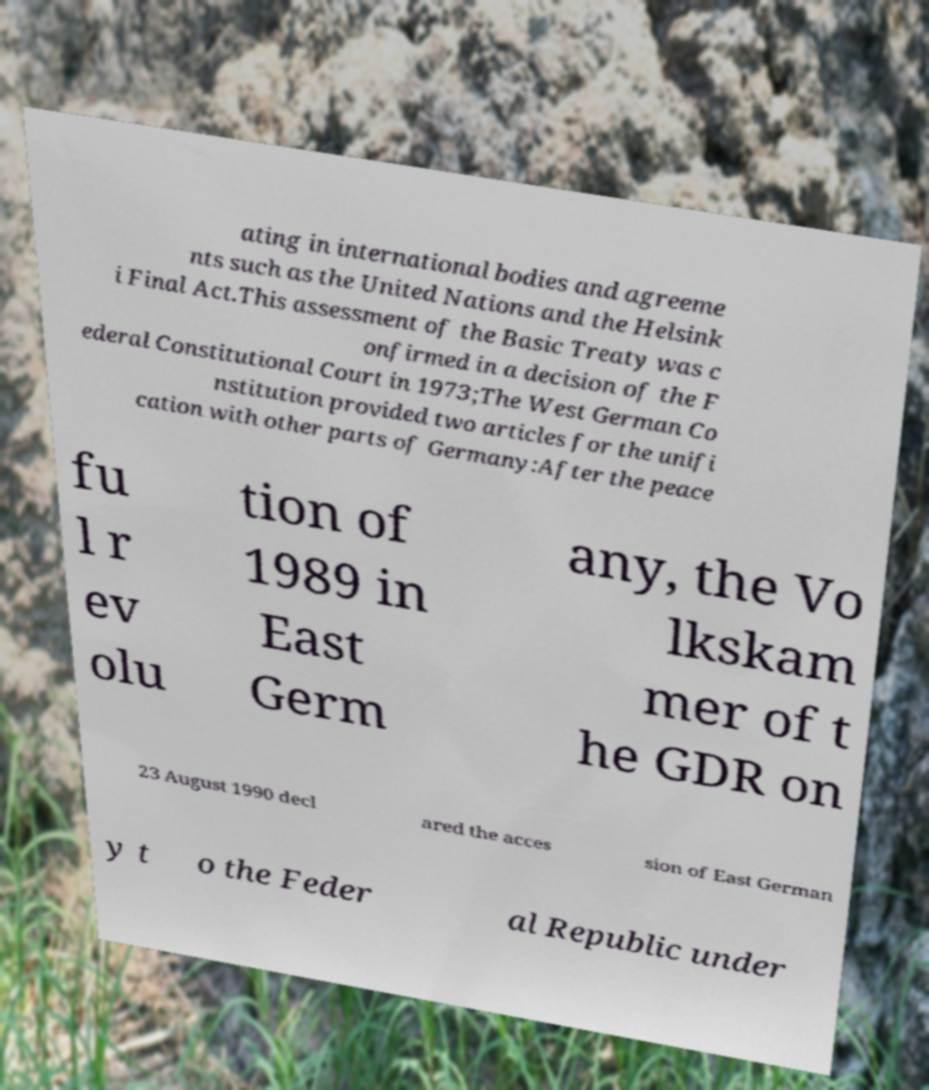What messages or text are displayed in this image? I need them in a readable, typed format. ating in international bodies and agreeme nts such as the United Nations and the Helsink i Final Act.This assessment of the Basic Treaty was c onfirmed in a decision of the F ederal Constitutional Court in 1973;The West German Co nstitution provided two articles for the unifi cation with other parts of Germany:After the peace fu l r ev olu tion of 1989 in East Germ any, the Vo lkskam mer of t he GDR on 23 August 1990 decl ared the acces sion of East German y t o the Feder al Republic under 